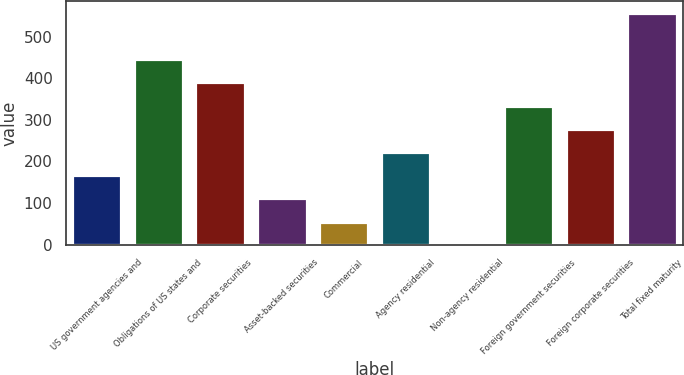Convert chart. <chart><loc_0><loc_0><loc_500><loc_500><bar_chart><fcel>US government agencies and<fcel>Obligations of US states and<fcel>Corporate securities<fcel>Asset-backed securities<fcel>Commercial<fcel>Agency residential<fcel>Non-agency residential<fcel>Foreign government securities<fcel>Foreign corporate securities<fcel>Total fixed maturity<nl><fcel>167.18<fcel>445.48<fcel>389.82<fcel>111.52<fcel>55.86<fcel>222.84<fcel>0.2<fcel>334.16<fcel>278.5<fcel>556.8<nl></chart> 